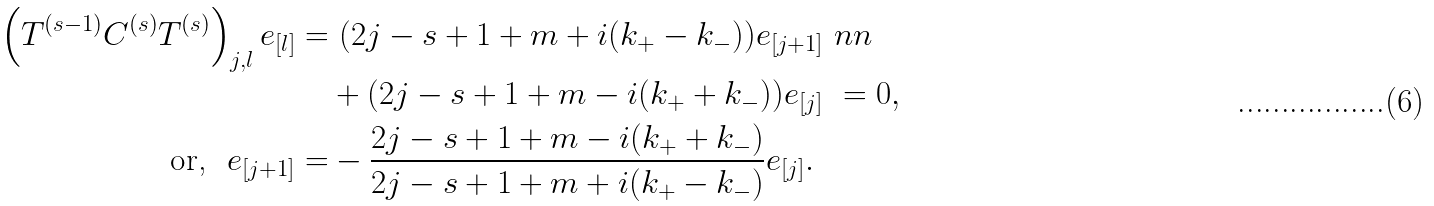<formula> <loc_0><loc_0><loc_500><loc_500>\left ( T ^ { ( s - 1 ) } C ^ { ( s ) } T ^ { ( s ) } \right ) _ { j , l } e _ { [ l ] } = & \ ( 2 j - s + 1 + m + i ( k _ { + } - k _ { - } ) ) e _ { [ j + 1 ] } \ n n \\ & + ( 2 j - s + 1 + m - i ( k _ { + } + k _ { - } ) ) e _ { [ j ] } \ = 0 , \\ \text {or,} \ \ e _ { [ j + 1 ] } = & - \frac { 2 j - s + 1 + m - i ( k _ { + } + k _ { - } ) } { 2 j - s + 1 + m + i ( k _ { + } - k _ { - } ) } e _ { [ j ] } .</formula> 